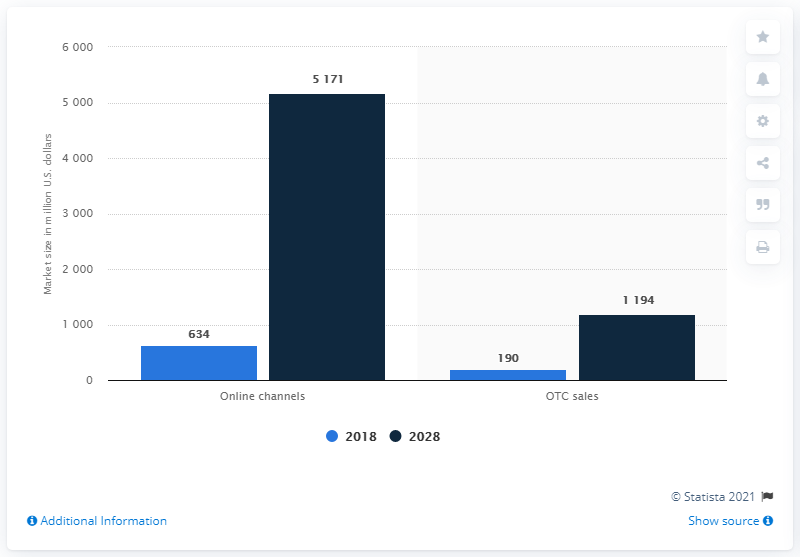Draw attention to some important aspects in this diagram. In 2018, the global DTC genetic testing market was approximately 190... According to projections, the global OTC sales market is expected to reach a significant growth of 1194% by 2028. 